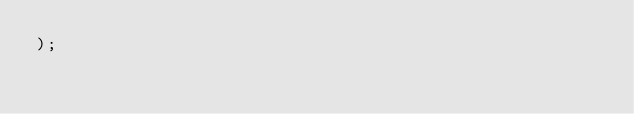Convert code to text. <code><loc_0><loc_0><loc_500><loc_500><_SQL_>);
</code> 